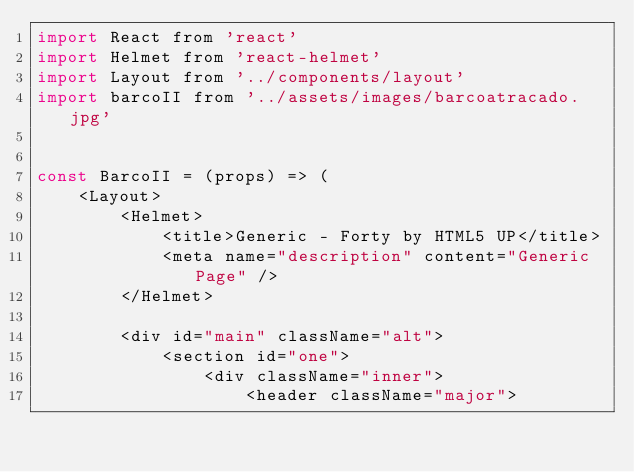Convert code to text. <code><loc_0><loc_0><loc_500><loc_500><_JavaScript_>import React from 'react'
import Helmet from 'react-helmet'
import Layout from '../components/layout'
import barcoII from '../assets/images/barcoatracado.jpg'


const BarcoII = (props) => (
    <Layout>
        <Helmet>
            <title>Generic - Forty by HTML5 UP</title>
            <meta name="description" content="Generic Page" />
        </Helmet>

        <div id="main" className="alt">
            <section id="one">
                <div className="inner">
                    <header className="major"></code> 